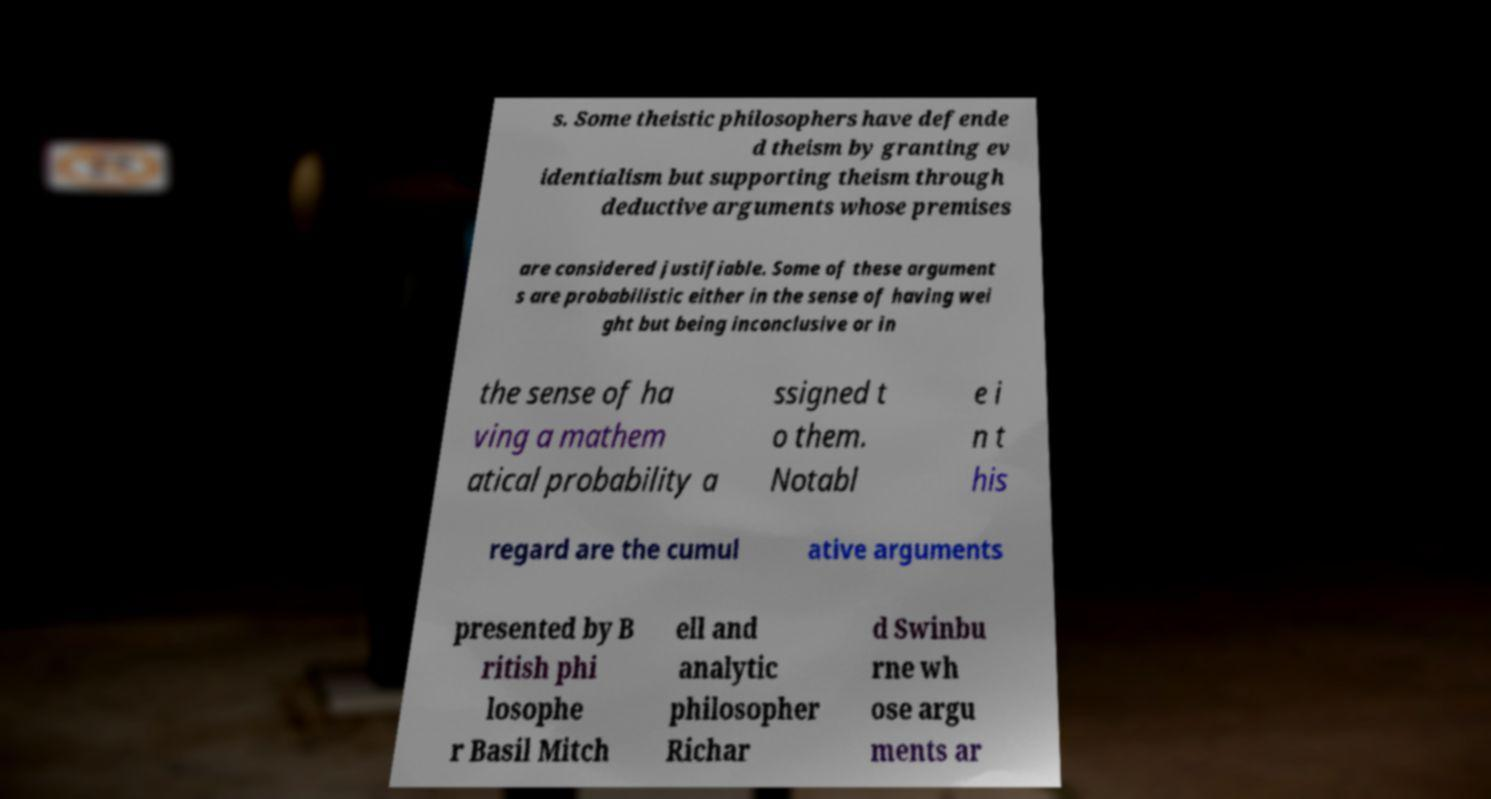Please identify and transcribe the text found in this image. s. Some theistic philosophers have defende d theism by granting ev identialism but supporting theism through deductive arguments whose premises are considered justifiable. Some of these argument s are probabilistic either in the sense of having wei ght but being inconclusive or in the sense of ha ving a mathem atical probability a ssigned t o them. Notabl e i n t his regard are the cumul ative arguments presented by B ritish phi losophe r Basil Mitch ell and analytic philosopher Richar d Swinbu rne wh ose argu ments ar 